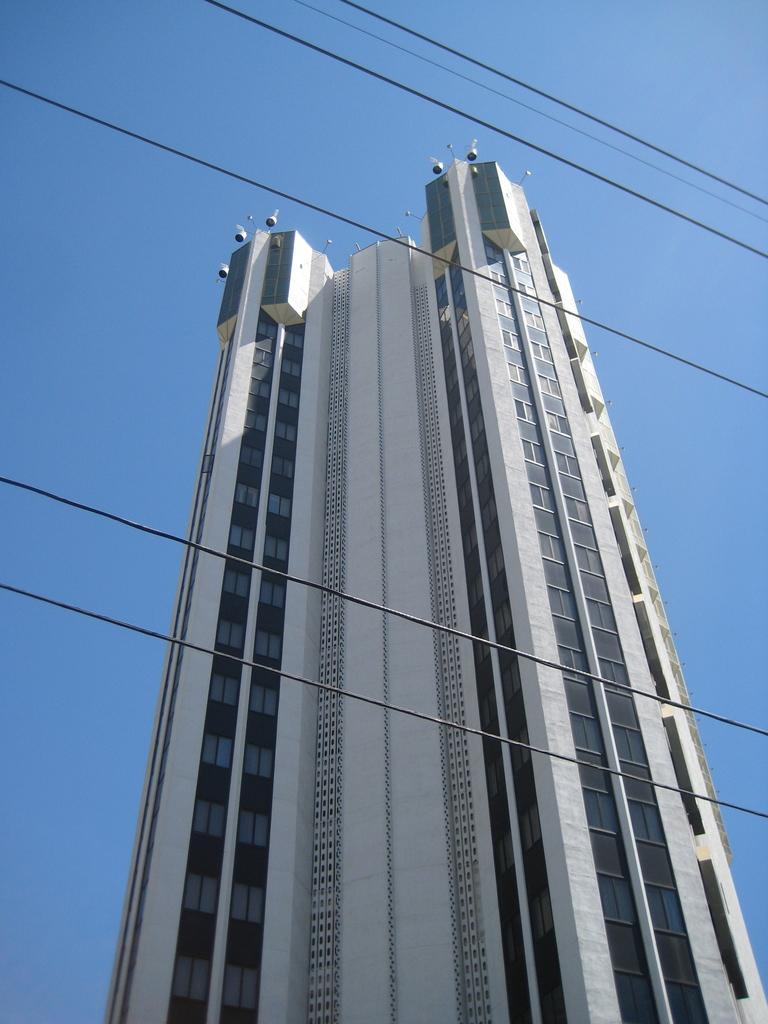In one or two sentences, can you explain what this image depicts? in the center of the image there is a building and we can see wires. In the background there is sky. 